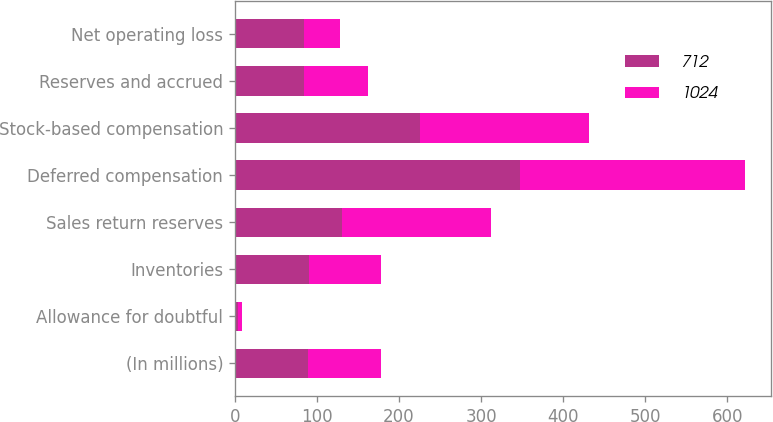Convert chart. <chart><loc_0><loc_0><loc_500><loc_500><stacked_bar_chart><ecel><fcel>(In millions)<fcel>Allowance for doubtful<fcel>Inventories<fcel>Sales return reserves<fcel>Deferred compensation<fcel>Stock-based compensation<fcel>Reserves and accrued<fcel>Net operating loss<nl><fcel>712<fcel>89<fcel>4<fcel>90<fcel>130<fcel>348<fcel>225<fcel>84<fcel>84<nl><fcel>1024<fcel>89<fcel>5<fcel>88<fcel>182<fcel>274<fcel>206<fcel>78<fcel>44<nl></chart> 